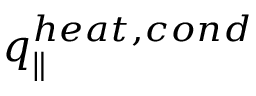Convert formula to latex. <formula><loc_0><loc_0><loc_500><loc_500>q _ { \| } ^ { h e a t , c o n d }</formula> 